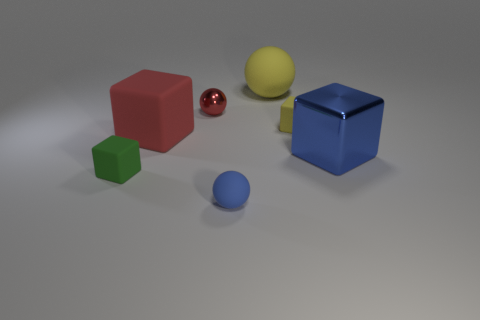Is there a tiny object that has the same color as the metal cube?
Your response must be concise. Yes. What is the size of the ball that is the same color as the shiny cube?
Make the answer very short. Small. How many objects are small metallic spheres or cubes that are to the right of the tiny green matte thing?
Your response must be concise. 4. What is the size of the yellow sphere that is the same material as the big red object?
Make the answer very short. Large. There is a small thing that is left of the big rubber object on the left side of the big matte ball; what shape is it?
Your answer should be compact. Cube. What number of red objects are either metal cubes or balls?
Give a very brief answer. 1. Is there a tiny green matte thing that is right of the matte block behind the red object that is in front of the small metallic object?
Provide a succinct answer. No. What is the shape of the shiny thing that is the same color as the tiny matte ball?
Provide a short and direct response. Cube. How many big objects are either green matte cubes or brown rubber cylinders?
Your response must be concise. 0. Does the blue object behind the small blue thing have the same shape as the green thing?
Ensure brevity in your answer.  Yes. 